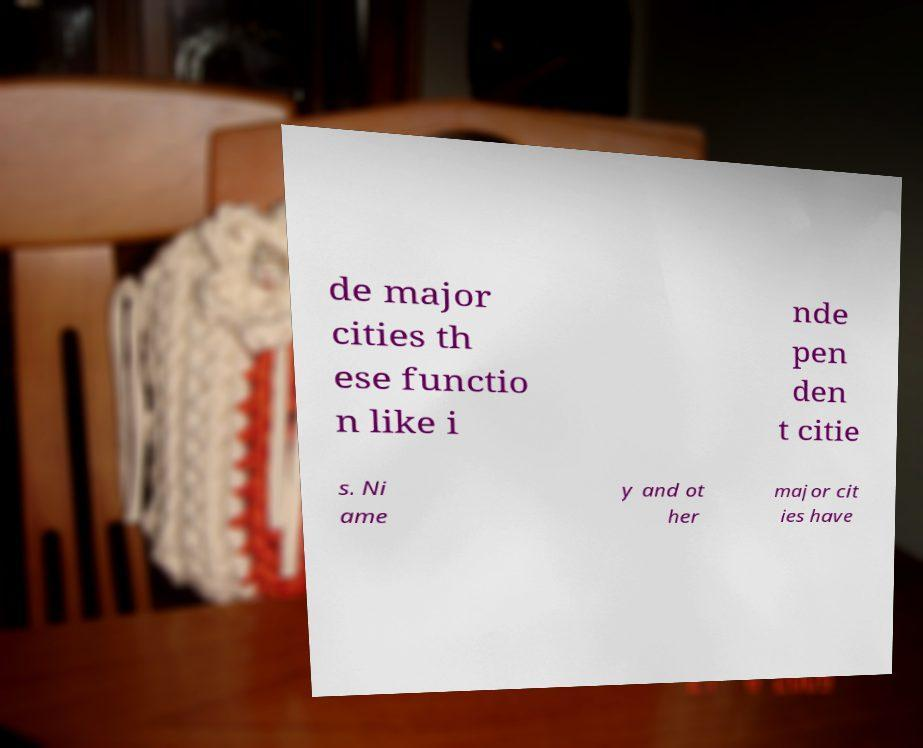Please read and relay the text visible in this image. What does it say? de major cities th ese functio n like i nde pen den t citie s. Ni ame y and ot her major cit ies have 